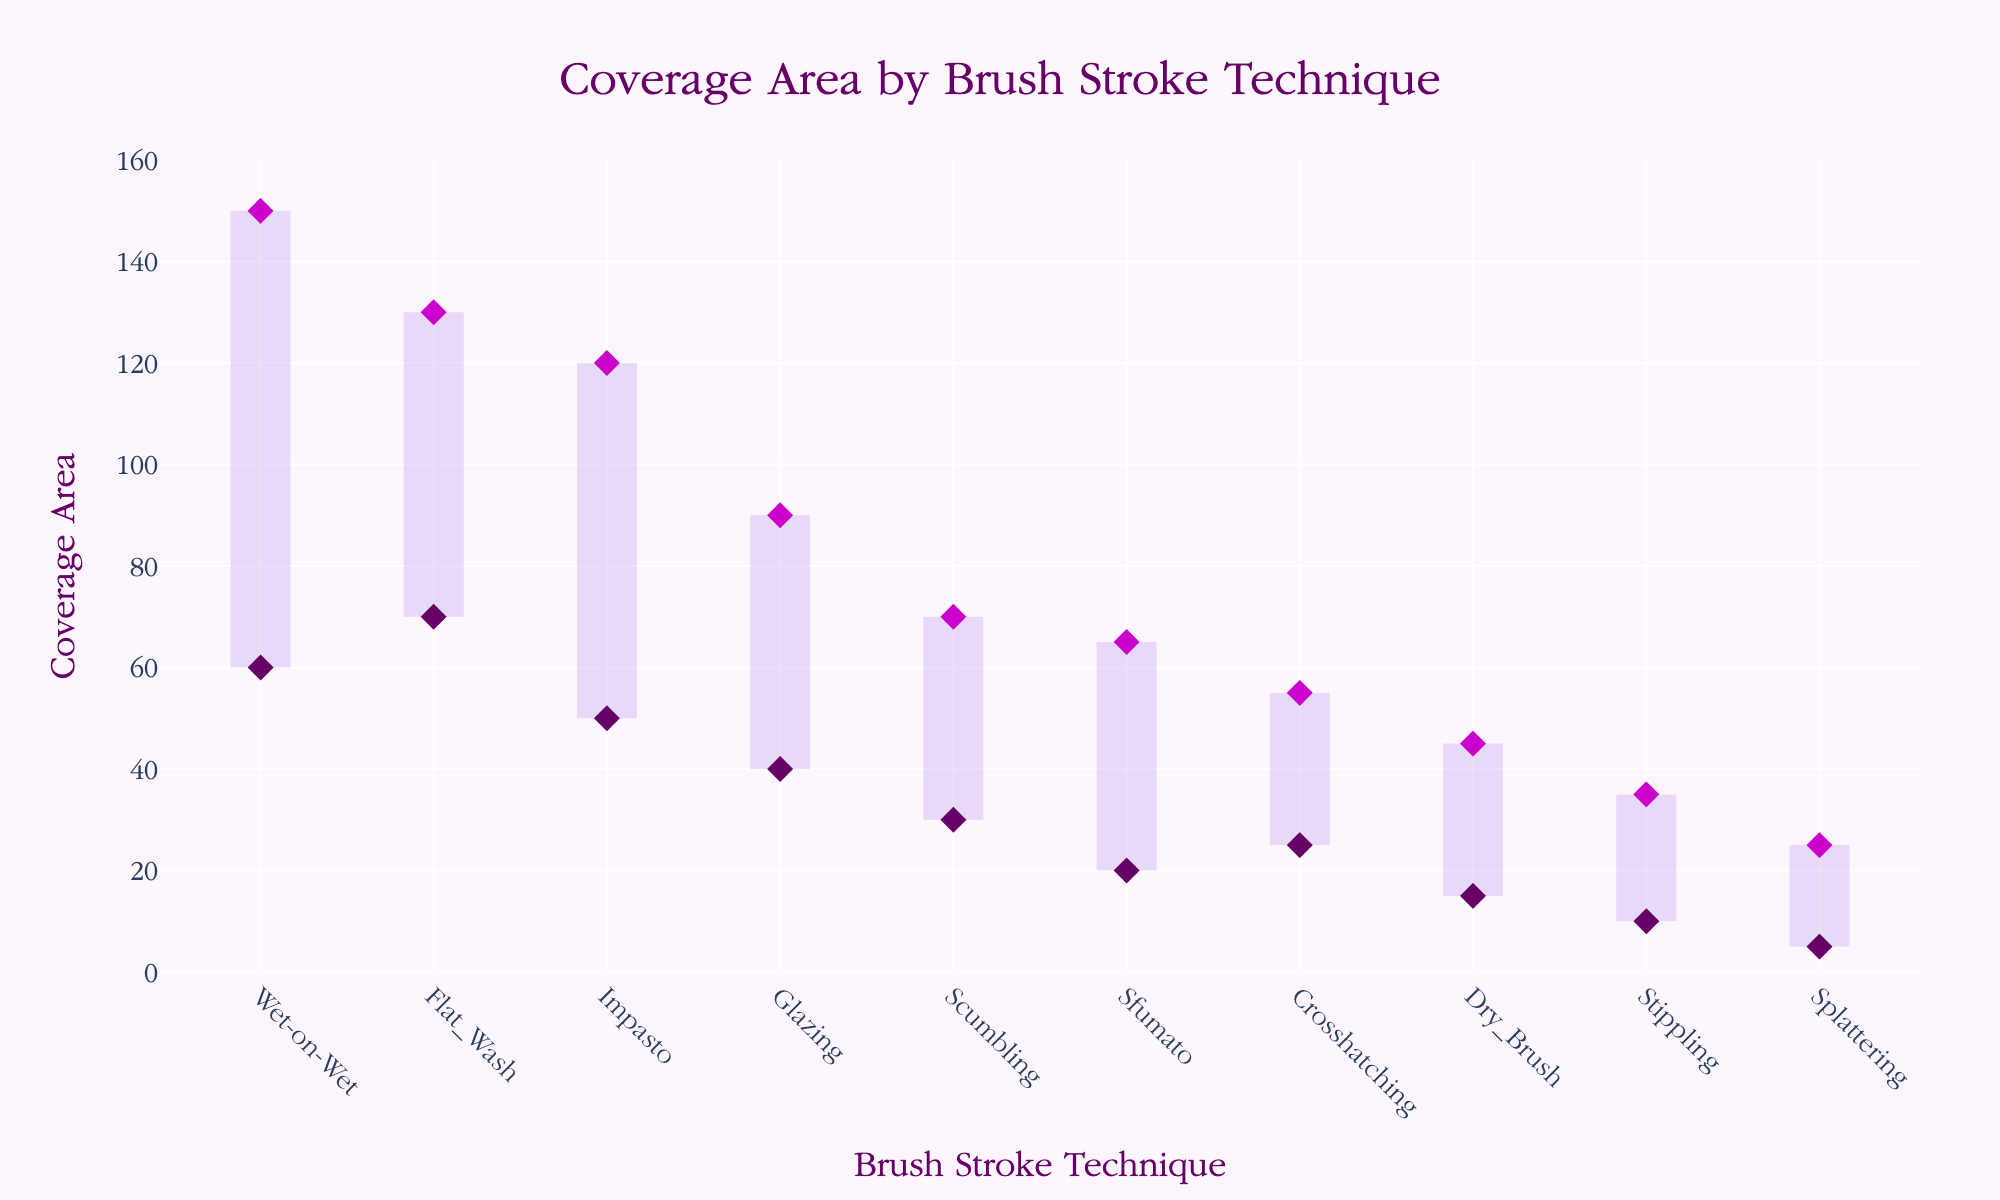What's the title of the range area chart? The title of the chart is displayed at the top and centers around the information it provides. In this case, it should be about the coverage area of different brush strokes.
Answer: Coverage Area by Brush Stroke Technique Which brush stroke technique has the smallest range in coverage area? To find the smallest range, look at the difference between the maximum and minimum coverage areas for each technique. Stippling has a range from 10 to 35, which is 25, the smallest among all techniques.
Answer: Stippling What is the maximum coverage area for the Wet-on-Wet technique? Locate the entry for Wet-on-Wet and check its maximum coverage area value. According to the chart, Wet-on-Wet has the highest maximum coverage area.
Answer: 150 Which technique has the highest minimum coverage area? Compare the minimum coverage area values for all techniques. The Flat Wash technique has a minimum coverage area of 70, the highest among all.
Answer: Flat Wash Calculate the average coverage area range for Dry Brush and Glazing techniques. First, find the ranges: Dry Brush (45-15=30) and Glazing (90-40=50). Then, find the average of 30 and 50: (30+50)/2 = 40.
Answer: 40 Which technique has a lower maximum coverage area than Glazing but higher than Stippling? Glazing has a max coverage area of 90 and Stippling has 35. The technique that fits between these is Scumbling, with a max coverage area of 70.
Answer: Scumbling What is the total range of coverage areas for the Impasto and Crosshatching techniques? Calculate the ranges for both techniques: Impasto (120-50=70) and Crosshatching (55-25=30). Then add them up: 70 + 30 = 100.
Answer: 100 How many techniques have a minimum coverage area of 40 or greater? Look for techniques where the minimum coverage area is 40 or greater: Glazing (40), Flat Wash (70), Impasto (50), and Wet-on-Wet (60). That's 4 techniques.
Answer: 4 Is the minimum coverage area of Sfumato greater than the maximum coverage area of Splattering? Compare the minimum of Sfumato (20) with the maximum of Splattering (25). Since 20 is less than 25, the statement is false.
Answer: No 